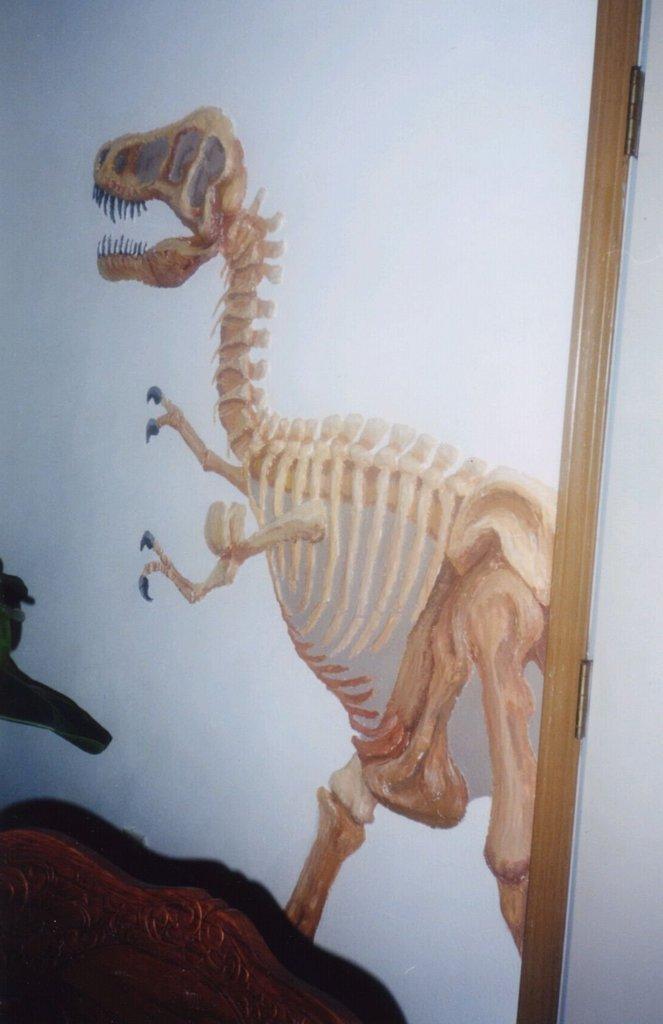Could you give a brief overview of what you see in this image? At the bottom there is a wooden object. In the center of the picture there is a dinosaur poster on the wall. On the right there is a wooden object. 